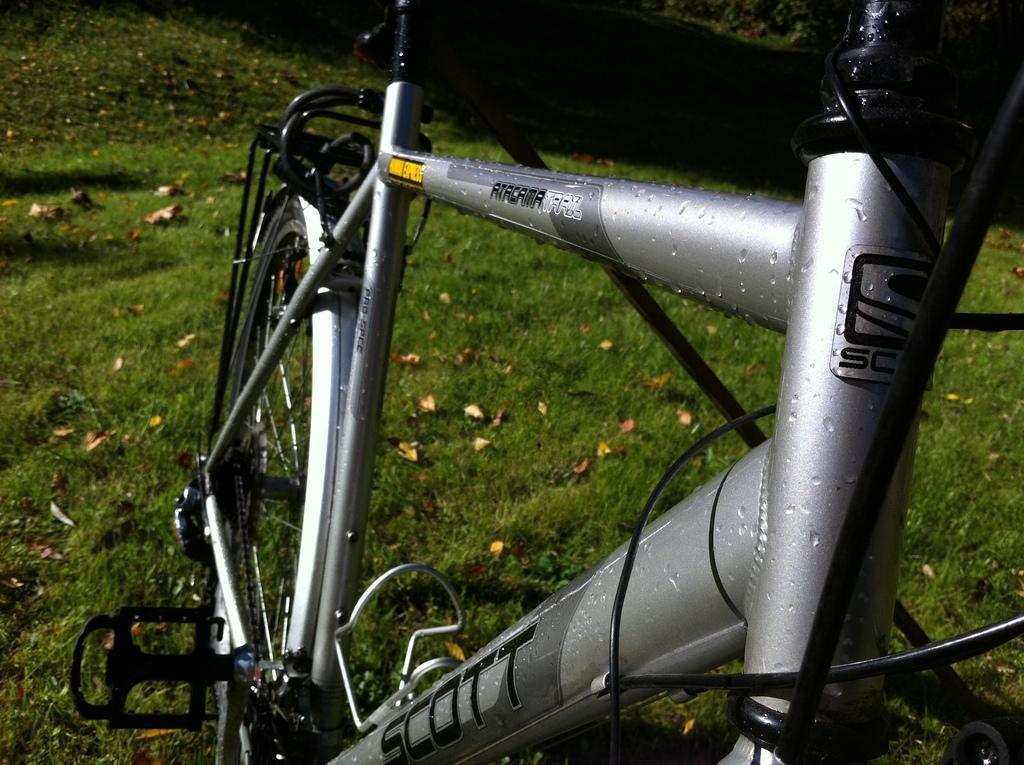Describe this image in one or two sentences. In this image we can see a grey color bicycle on the grassy land and we can see some dry leaves on the grassy land. 